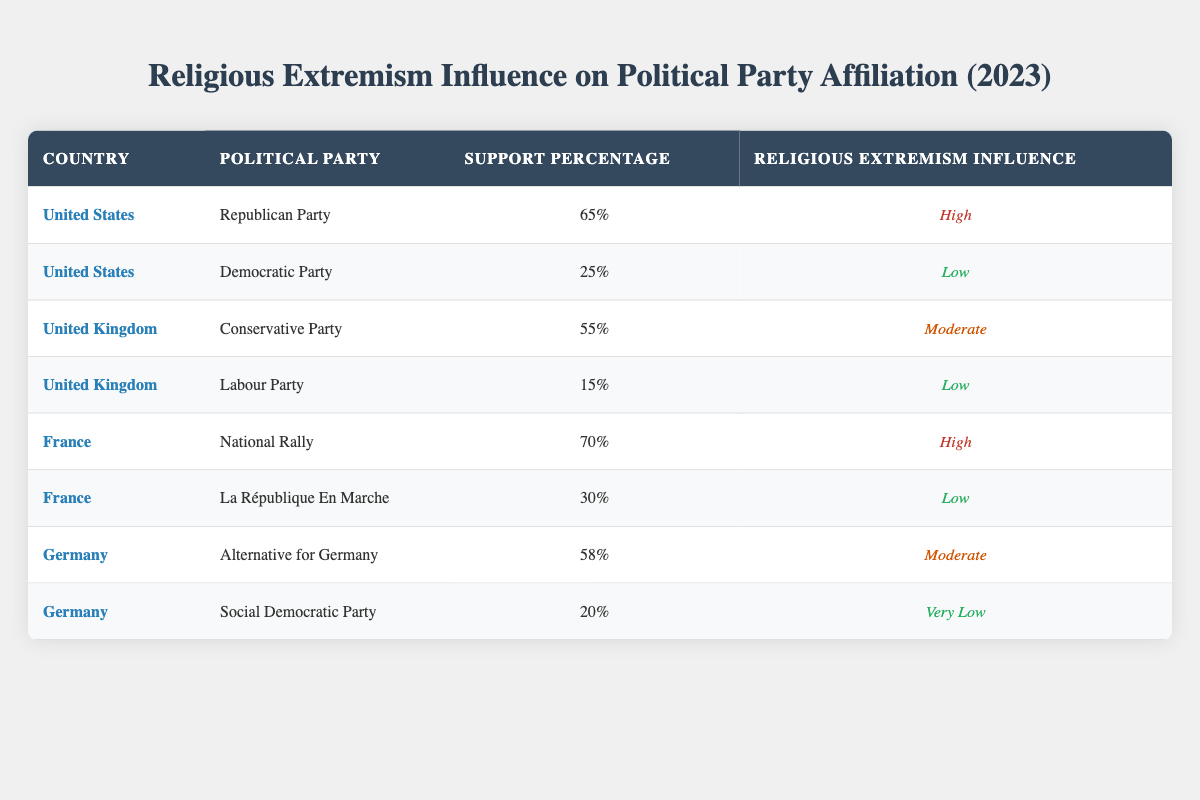What percentage of support does the Republican Party receive in the United States regarding the influence of religious extremism? According to the table, the Republican Party in the United States has a support percentage of 65%.
Answer: 65% What is the influence of religious extremism on the Labour Party in the United Kingdom? The table shows that the influence of religious extremism on the Labour Party is categorized as Low.
Answer: Low Which political party in France has the highest support percentage and what is its level of religious extremism influence? The National Rally has the highest support percentage in France at 70%, with a high level of influence from religious extremism.
Answer: National Rally, High What is the average support percentage of political parties in the United States? To find the average, we calculate the support percentages for the Republican (65%) and Democratic (25%) parties: (65 + 25) / 2 = 45%.
Answer: 45% Is the influence of religious extremism on the Social Democratic Party in Germany categorized as high? The data indicates that the influence of religious extremism on the Social Democratic Party is categorized as Very Low, therefore the statement is false.
Answer: No Which UK party has a higher percentage of support, the Conservative Party or the Labour Party, and by how much? The Conservative Party has a support percentage of 55% while the Labour Party has 15%. The difference is 55 - 15 = 40%.
Answer: 40% In which country does the National Rally have higher support compared to the Alternative for Germany, and what is the difference in their support? The National Rally in France has 70% support, while the Alternative for Germany in Germany has 58% support. The difference is 70 - 58 = 12%.
Answer: France, 12% Does the Democratic Party in the United States have more support than the Labour Party in the United Kingdom? The Democratic Party has 25% support and the Labour Party has 15% support. Since 25% is greater than 15%, the statement is true.
Answer: Yes What is the total percentage support for political parties in Germany? The parties are the Alternative for Germany (58%) and the Social Democratic Party (20%). Adding these gives 58 + 20 = 78%.
Answer: 78% 